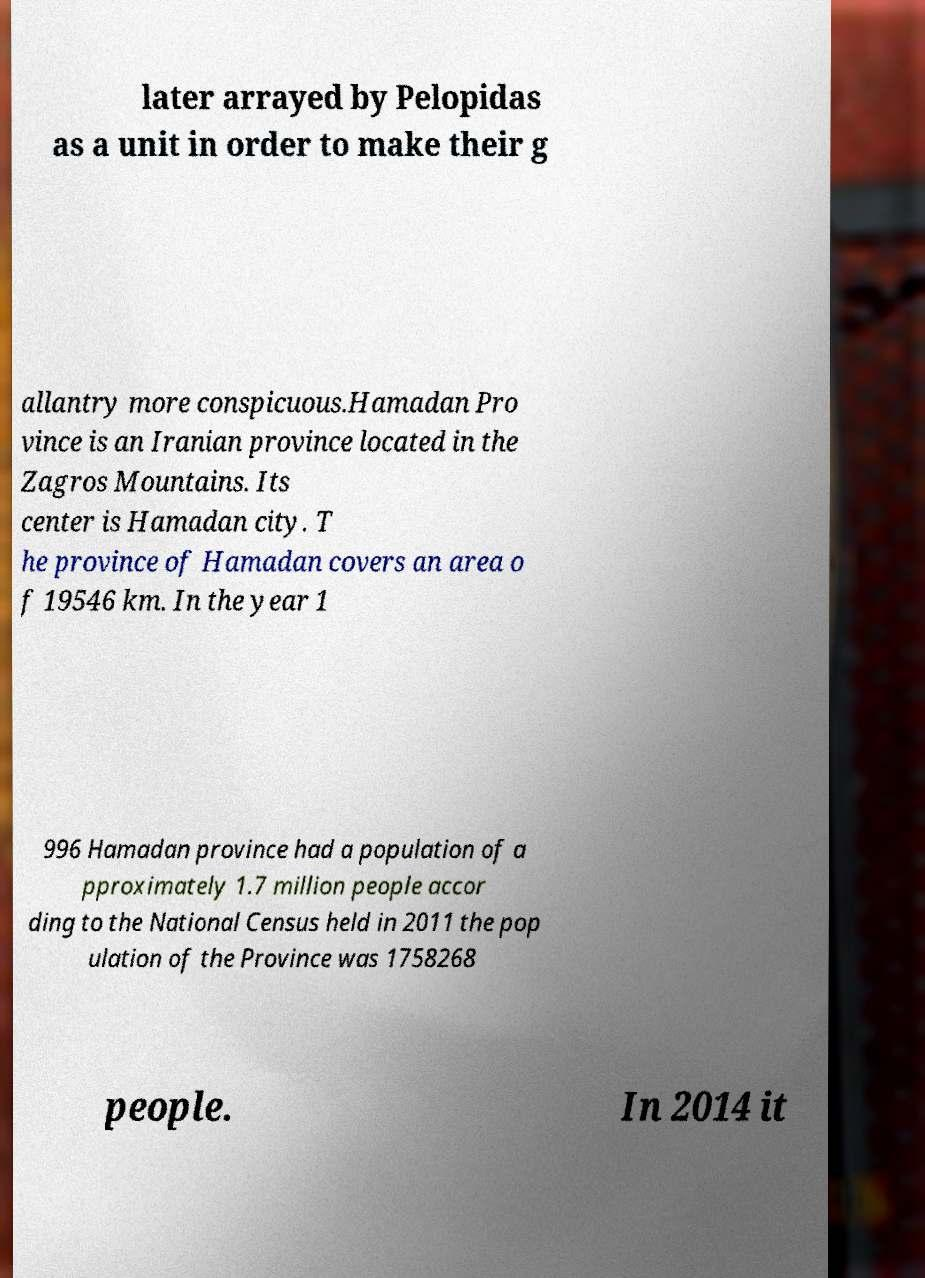What messages or text are displayed in this image? I need them in a readable, typed format. later arrayed by Pelopidas as a unit in order to make their g allantry more conspicuous.Hamadan Pro vince is an Iranian province located in the Zagros Mountains. Its center is Hamadan city. T he province of Hamadan covers an area o f 19546 km. In the year 1 996 Hamadan province had a population of a pproximately 1.7 million people accor ding to the National Census held in 2011 the pop ulation of the Province was 1758268 people. In 2014 it 